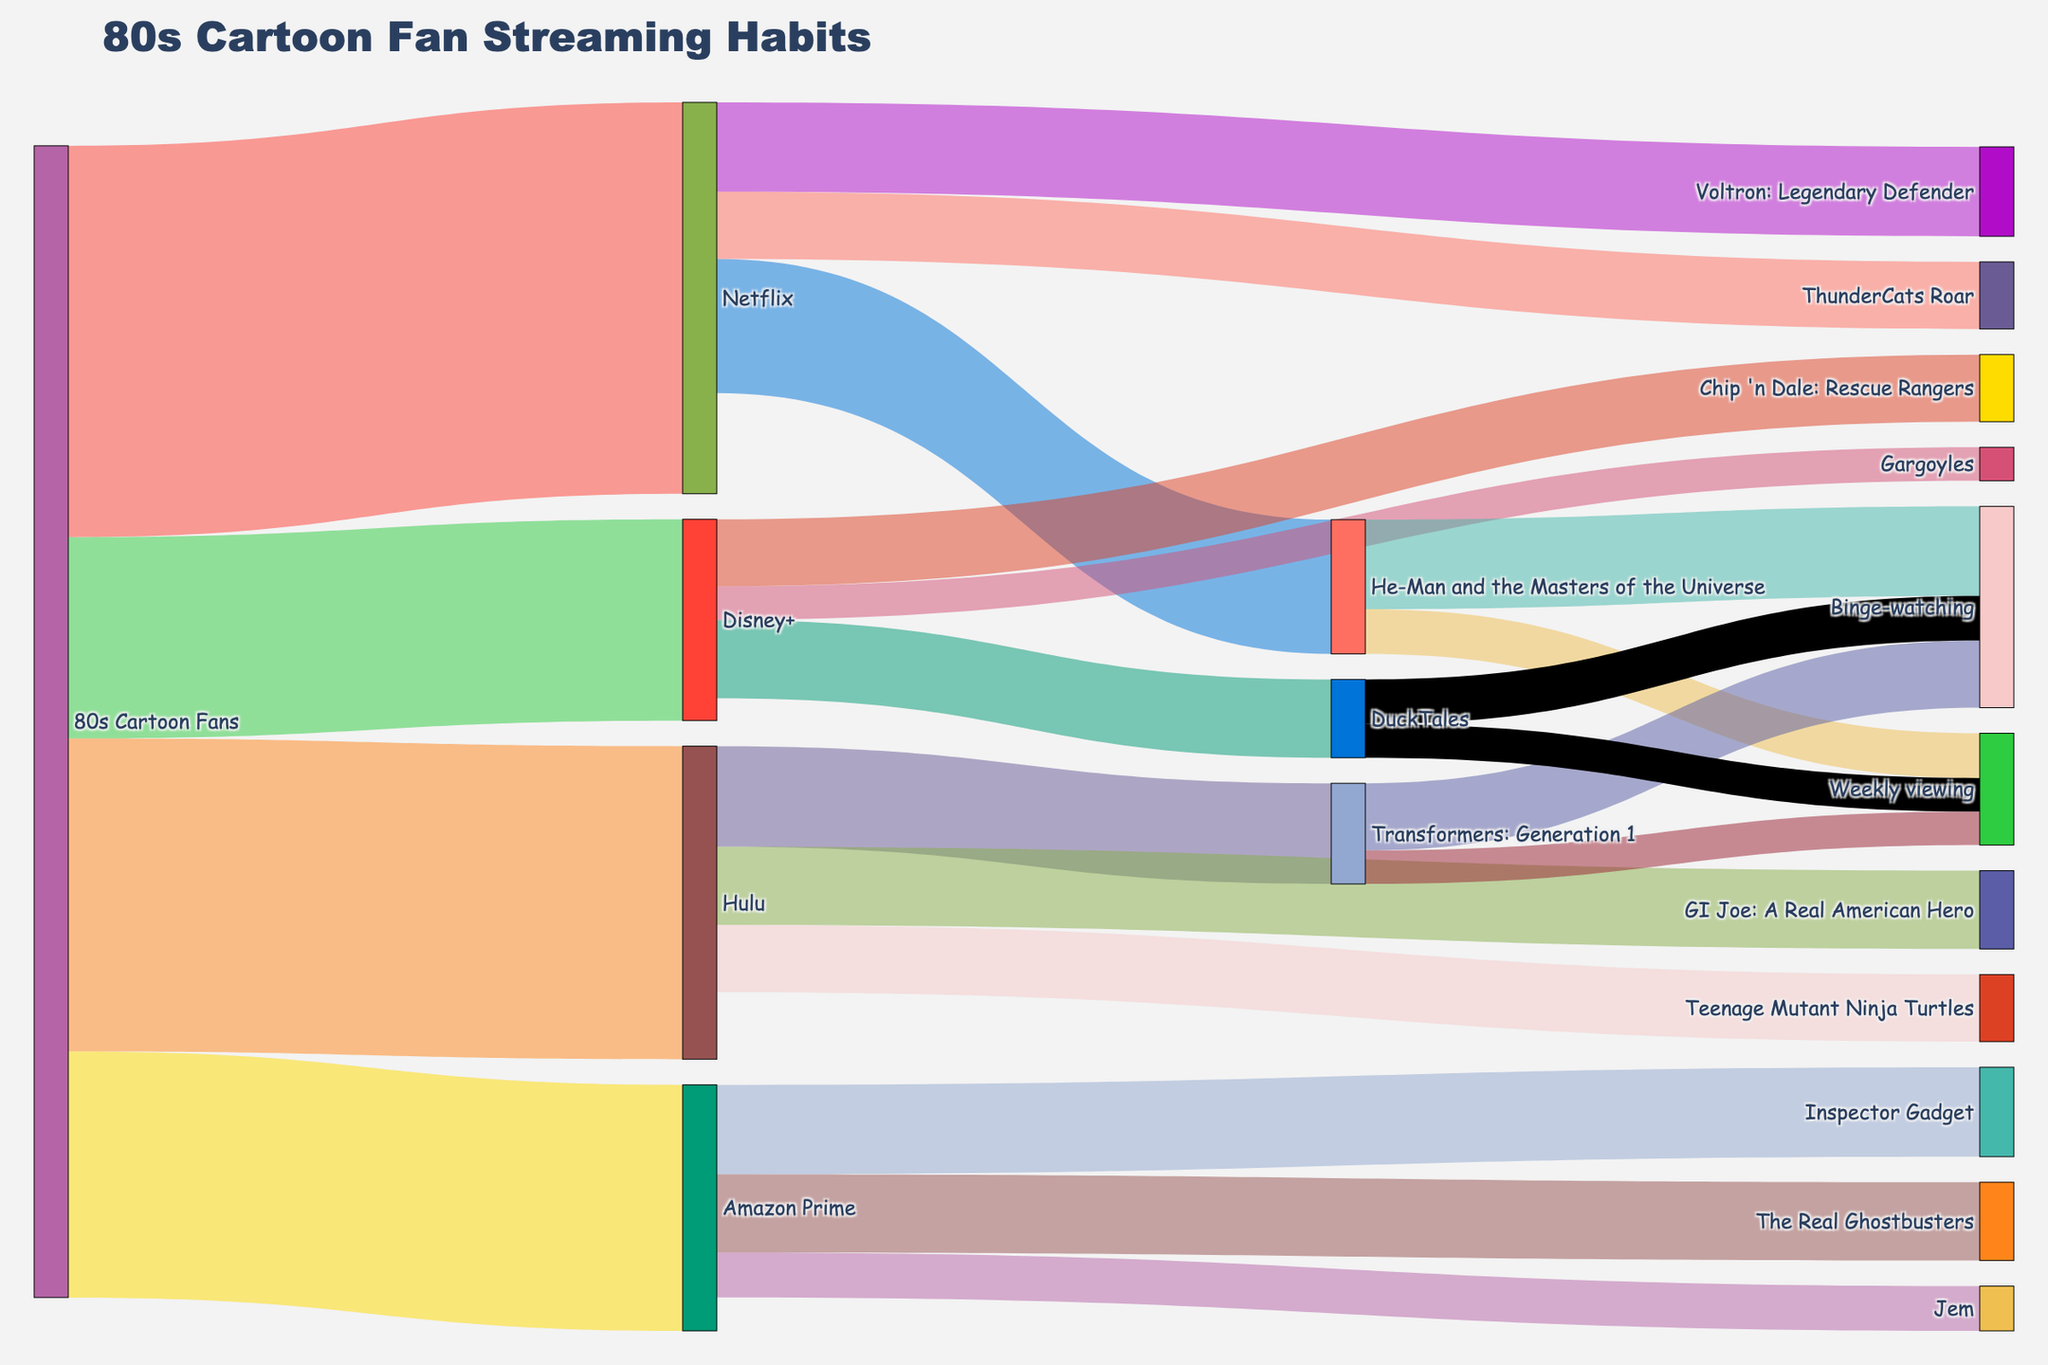What's the most popular streaming platform among 80s cartoon fans? The tallest bar in the diagram represents the largest value, which indicates popularity. We observe that Netflix has the highest value (3500).
Answer: Netflix Which cartoon on Netflix has the highest number of fans? To find this, look for the Netflix node and trace the lines to the cartoons it connects to. The cartoon with the highest value connected to Netflix is "He-Man and the Masters of the Universe" with 1200 fans.
Answer: He-Man and the Masters of the Universe How many fans watch "DuckTales" on Disney+ either by binge-watching or weekly viewing? Look at the "DuckTales" node on Disney+. The values are 400 (binge-watching) and 300 (weekly viewing). Adding them, we get 400 + 300 = 700.
Answer: 700 Which cartoon on Hulu has the least number of fans? Look at the Hulu node and trace the connections. The cartoon with the lowest value connected to Hulu is "Teenage Mutant Ninja Turtles" with 600 fans.
Answer: Teenage Mutant Ninja Turtles What's the total number of fans who prefer binge-watching over weekly viewing for "He-Man and the Masters of the Universe" and "Transformers: Generation 1"? Identify the number of fans who binge-watch and watch weekly for both cartoons. Sum the binge-watching values: 800 (He-Man) + 600 (Transformers). Thus, the total is 800 + 600 = 1400.
Answer: 1400 Which streaming platform has the smallest number of 80s cartoon fans? Observe the smallest value among the platforms. Disney+ has the smallest value with 1800 fans.
Answer: Disney+ Compare the number of fans who watch "Inspector Gadget" on Amazon Prime to "Gargoyles" on Disney+. Which is higher and by how much? Look at the values for "Inspector Gadget" (800) and "Gargoyles" (300). The difference is 800 - 300 = 500. "Inspector Gadget" has 500 more fans.
Answer: Inspector Gadget by 500 What’s the total number of fans for all cartoons provided by Amazon Prime? Sum the values for all cartoons linked to Amazon Prime: 800 (Inspector Gadget) + 700 (The Real Ghostbusters) + 400 (Jem) = 1900.
Answer: 1900 What's the combined number of fans for "Transformers: Generation 1" and "GI Joe: A Real American Hero" on Hulu? Add the number of fans for both cartoons on Hulu: 900 (Transformers) + 700 (GI Joe) = 1600.
Answer: 1600 Which cartoon on Disney+ has the highest number of fans? Look for the highest value among the cartoons linked to Disney+. "DuckTales" has the most with 700 fans.
Answer: DuckTales 